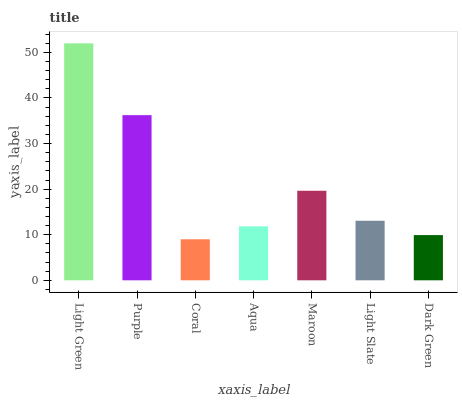Is Coral the minimum?
Answer yes or no. Yes. Is Light Green the maximum?
Answer yes or no. Yes. Is Purple the minimum?
Answer yes or no. No. Is Purple the maximum?
Answer yes or no. No. Is Light Green greater than Purple?
Answer yes or no. Yes. Is Purple less than Light Green?
Answer yes or no. Yes. Is Purple greater than Light Green?
Answer yes or no. No. Is Light Green less than Purple?
Answer yes or no. No. Is Light Slate the high median?
Answer yes or no. Yes. Is Light Slate the low median?
Answer yes or no. Yes. Is Coral the high median?
Answer yes or no. No. Is Light Green the low median?
Answer yes or no. No. 